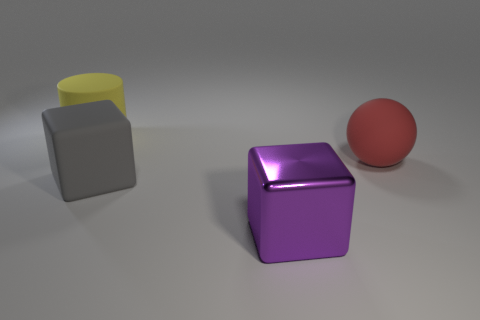Can you guess what time of day it might be based on the lighting in the image? The lighting in the image does not offer clear indications of a particular time of day, as it seems to be a controlled studio setting with a neutral grey background and soft, diffuse lighting. The shadows cast by the objects are relatively soft and do not point in a specific direction that would suggest a time of day. 